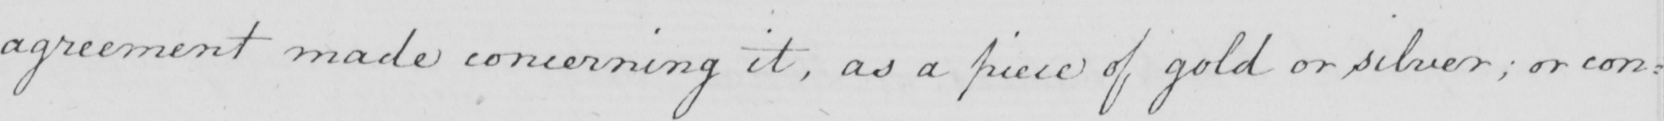Please transcribe the handwritten text in this image. agreement made concerning it , as a piece of gold or silver ; or con : 